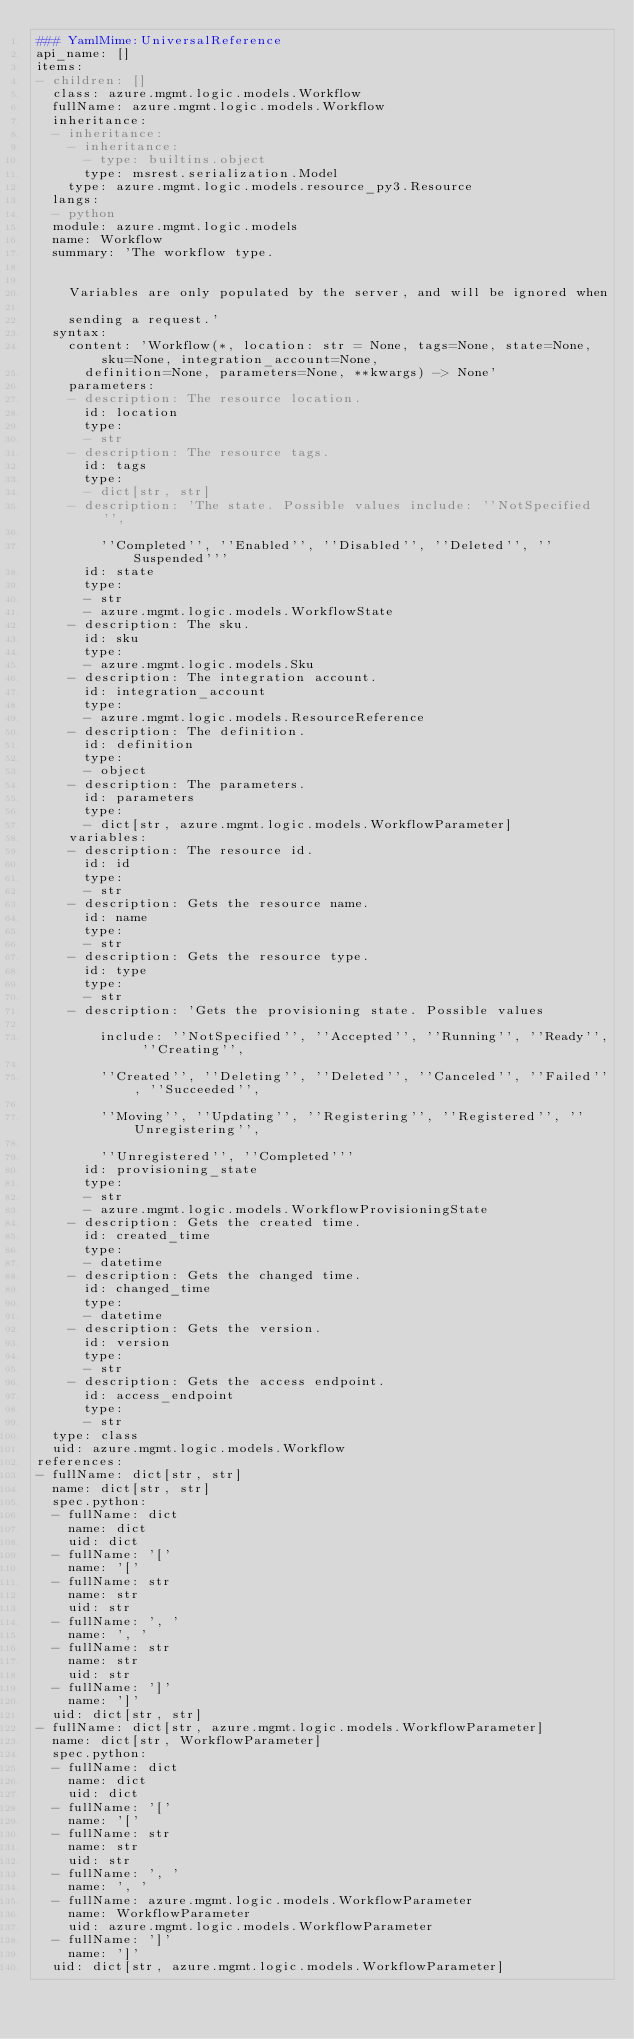Convert code to text. <code><loc_0><loc_0><loc_500><loc_500><_YAML_>### YamlMime:UniversalReference
api_name: []
items:
- children: []
  class: azure.mgmt.logic.models.Workflow
  fullName: azure.mgmt.logic.models.Workflow
  inheritance:
  - inheritance:
    - inheritance:
      - type: builtins.object
      type: msrest.serialization.Model
    type: azure.mgmt.logic.models.resource_py3.Resource
  langs:
  - python
  module: azure.mgmt.logic.models
  name: Workflow
  summary: 'The workflow type.


    Variables are only populated by the server, and will be ignored when

    sending a request.'
  syntax:
    content: 'Workflow(*, location: str = None, tags=None, state=None, sku=None, integration_account=None,
      definition=None, parameters=None, **kwargs) -> None'
    parameters:
    - description: The resource location.
      id: location
      type:
      - str
    - description: The resource tags.
      id: tags
      type:
      - dict[str, str]
    - description: 'The state. Possible values include: ''NotSpecified'',

        ''Completed'', ''Enabled'', ''Disabled'', ''Deleted'', ''Suspended'''
      id: state
      type:
      - str
      - azure.mgmt.logic.models.WorkflowState
    - description: The sku.
      id: sku
      type:
      - azure.mgmt.logic.models.Sku
    - description: The integration account.
      id: integration_account
      type:
      - azure.mgmt.logic.models.ResourceReference
    - description: The definition.
      id: definition
      type:
      - object
    - description: The parameters.
      id: parameters
      type:
      - dict[str, azure.mgmt.logic.models.WorkflowParameter]
    variables:
    - description: The resource id.
      id: id
      type:
      - str
    - description: Gets the resource name.
      id: name
      type:
      - str
    - description: Gets the resource type.
      id: type
      type:
      - str
    - description: 'Gets the provisioning state. Possible values

        include: ''NotSpecified'', ''Accepted'', ''Running'', ''Ready'', ''Creating'',

        ''Created'', ''Deleting'', ''Deleted'', ''Canceled'', ''Failed'', ''Succeeded'',

        ''Moving'', ''Updating'', ''Registering'', ''Registered'', ''Unregistering'',

        ''Unregistered'', ''Completed'''
      id: provisioning_state
      type:
      - str
      - azure.mgmt.logic.models.WorkflowProvisioningState
    - description: Gets the created time.
      id: created_time
      type:
      - datetime
    - description: Gets the changed time.
      id: changed_time
      type:
      - datetime
    - description: Gets the version.
      id: version
      type:
      - str
    - description: Gets the access endpoint.
      id: access_endpoint
      type:
      - str
  type: class
  uid: azure.mgmt.logic.models.Workflow
references:
- fullName: dict[str, str]
  name: dict[str, str]
  spec.python:
  - fullName: dict
    name: dict
    uid: dict
  - fullName: '['
    name: '['
  - fullName: str
    name: str
    uid: str
  - fullName: ', '
    name: ', '
  - fullName: str
    name: str
    uid: str
  - fullName: ']'
    name: ']'
  uid: dict[str, str]
- fullName: dict[str, azure.mgmt.logic.models.WorkflowParameter]
  name: dict[str, WorkflowParameter]
  spec.python:
  - fullName: dict
    name: dict
    uid: dict
  - fullName: '['
    name: '['
  - fullName: str
    name: str
    uid: str
  - fullName: ', '
    name: ', '
  - fullName: azure.mgmt.logic.models.WorkflowParameter
    name: WorkflowParameter
    uid: azure.mgmt.logic.models.WorkflowParameter
  - fullName: ']'
    name: ']'
  uid: dict[str, azure.mgmt.logic.models.WorkflowParameter]
</code> 